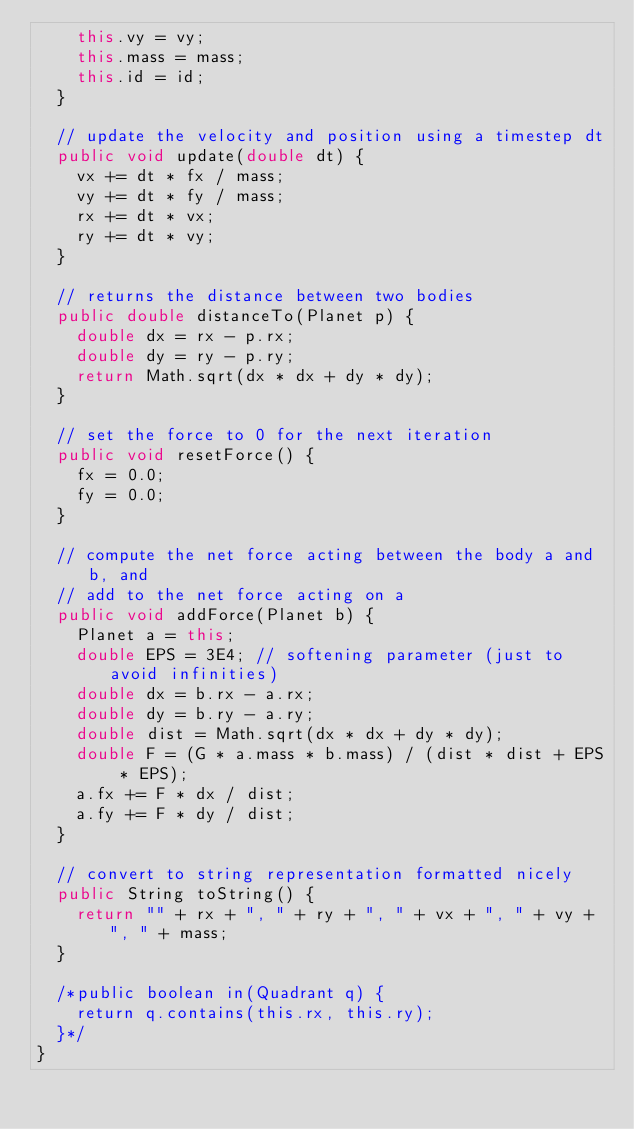<code> <loc_0><loc_0><loc_500><loc_500><_Java_>		this.vy = vy;
		this.mass = mass;
		this.id = id;
	}

	// update the velocity and position using a timestep dt
	public void update(double dt) {
		vx += dt * fx / mass;
		vy += dt * fy / mass;
		rx += dt * vx;
		ry += dt * vy;
	}

	// returns the distance between two bodies
	public double distanceTo(Planet p) {
		double dx = rx - p.rx;
		double dy = ry - p.ry;
		return Math.sqrt(dx * dx + dy * dy);
	}

	// set the force to 0 for the next iteration
	public void resetForce() {
		fx = 0.0;
		fy = 0.0;
	}

	// compute the net force acting between the body a and b, and
	// add to the net force acting on a
	public void addForce(Planet b) {
		Planet a = this;
		double EPS = 3E4; // softening parameter (just to avoid infinities)
		double dx = b.rx - a.rx;
		double dy = b.ry - a.ry;
		double dist = Math.sqrt(dx * dx + dy * dy);
		double F = (G * a.mass * b.mass) / (dist * dist + EPS * EPS);
		a.fx += F * dx / dist;
		a.fy += F * dy / dist;
	}

	// convert to string representation formatted nicely
	public String toString() {
		return "" + rx + ", " + ry + ", " + vx + ", " + vy + ", " + mass;
	}

	/*public boolean in(Quadrant q) {
		return q.contains(this.rx, this.ry);
	}*/
}
</code> 